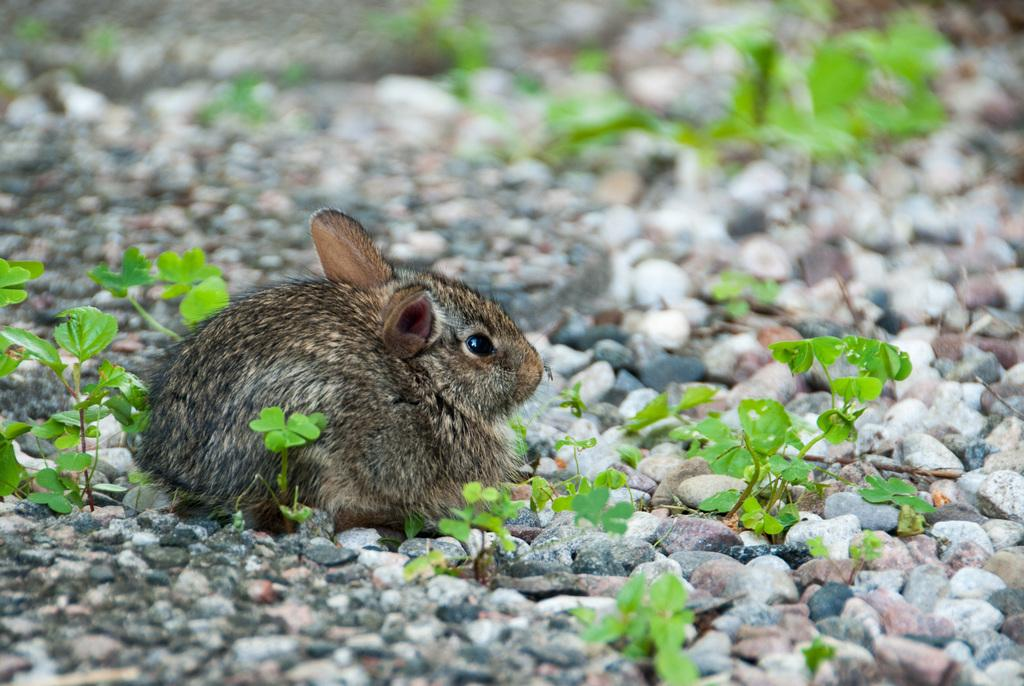What type of animal is in the image? There is a small rabbit in the image. Where is the rabbit located? The rabbit is on a surface. What else can be seen in the image besides the rabbit? There are baby plants in the image. How are the baby plants positioned in relation to the rabbit? The baby plants are beside the rabbit. What type of cap is the rabbit wearing in the image? There is no cap present in the image; the rabbit is not wearing any clothing. 